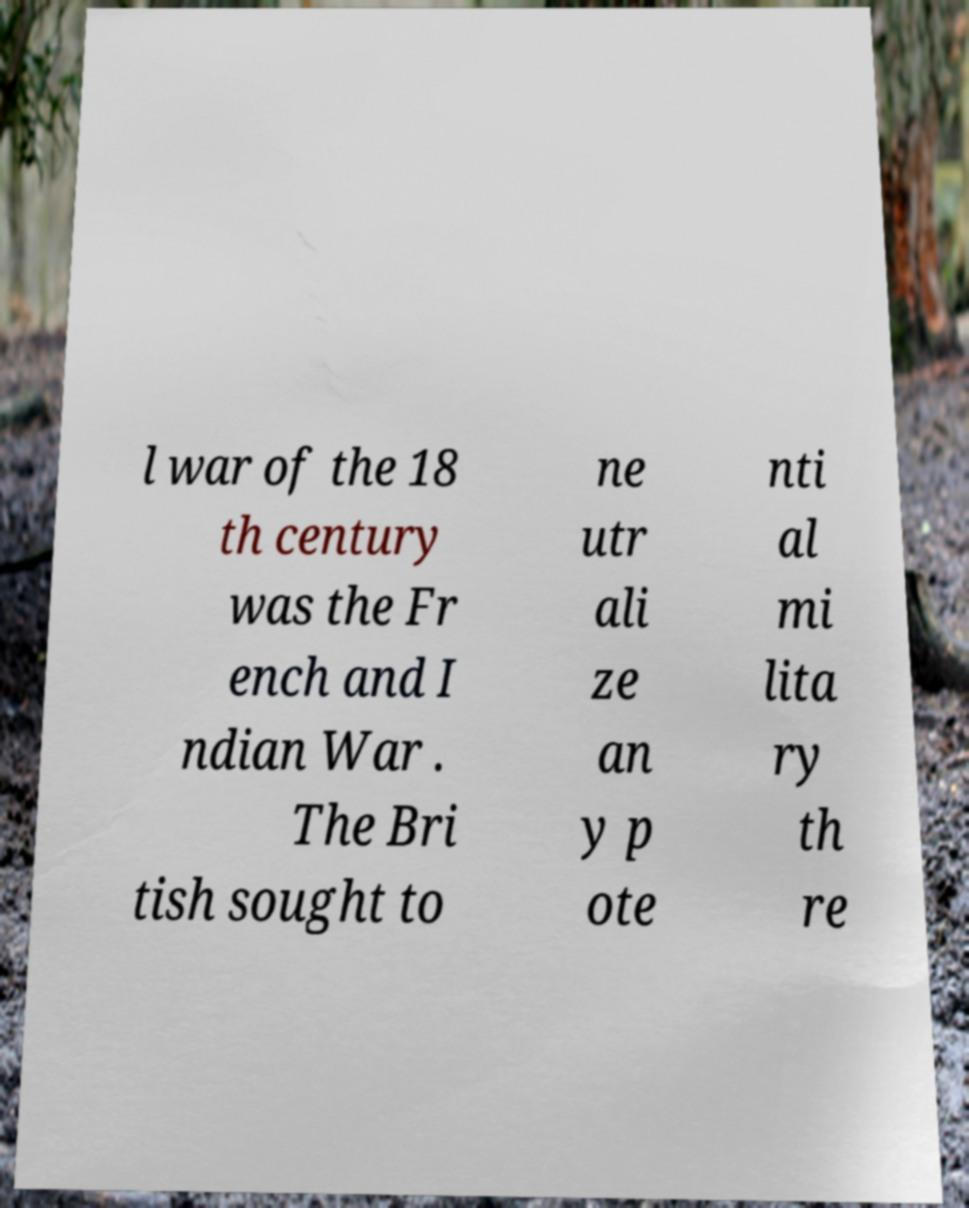Can you accurately transcribe the text from the provided image for me? l war of the 18 th century was the Fr ench and I ndian War . The Bri tish sought to ne utr ali ze an y p ote nti al mi lita ry th re 